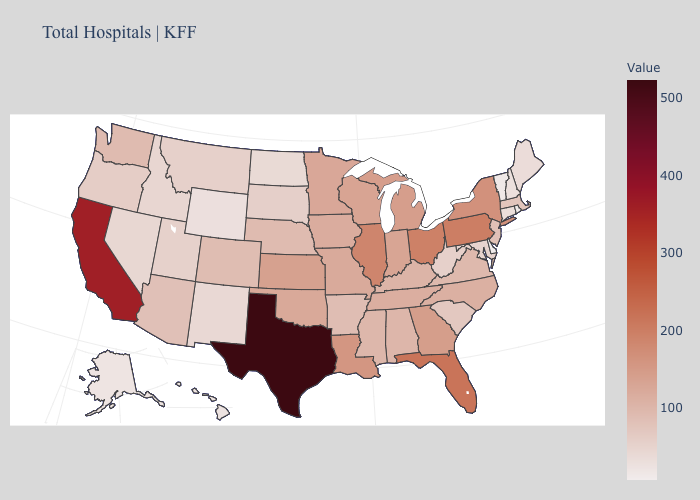Which states have the lowest value in the MidWest?
Concise answer only. North Dakota. Does West Virginia have a lower value than Indiana?
Keep it brief. Yes. Does Arizona have the lowest value in the West?
Keep it brief. No. Does Nevada have the highest value in the West?
Short answer required. No. Among the states that border Maine , which have the lowest value?
Keep it brief. New Hampshire. Which states have the lowest value in the USA?
Keep it brief. Delaware. 